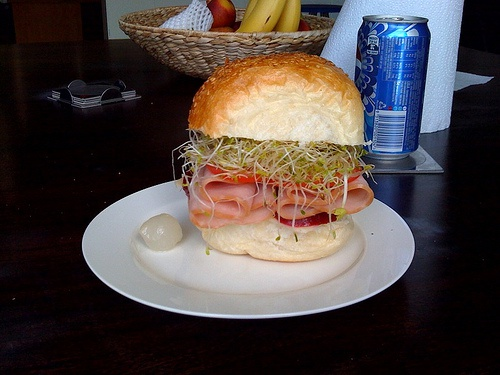Describe the objects in this image and their specific colors. I can see dining table in black, gray, and darkblue tones, sandwich in black, tan, brown, and salmon tones, banana in black, olive, and tan tones, apple in black, maroon, and brown tones, and apple in black and maroon tones in this image. 